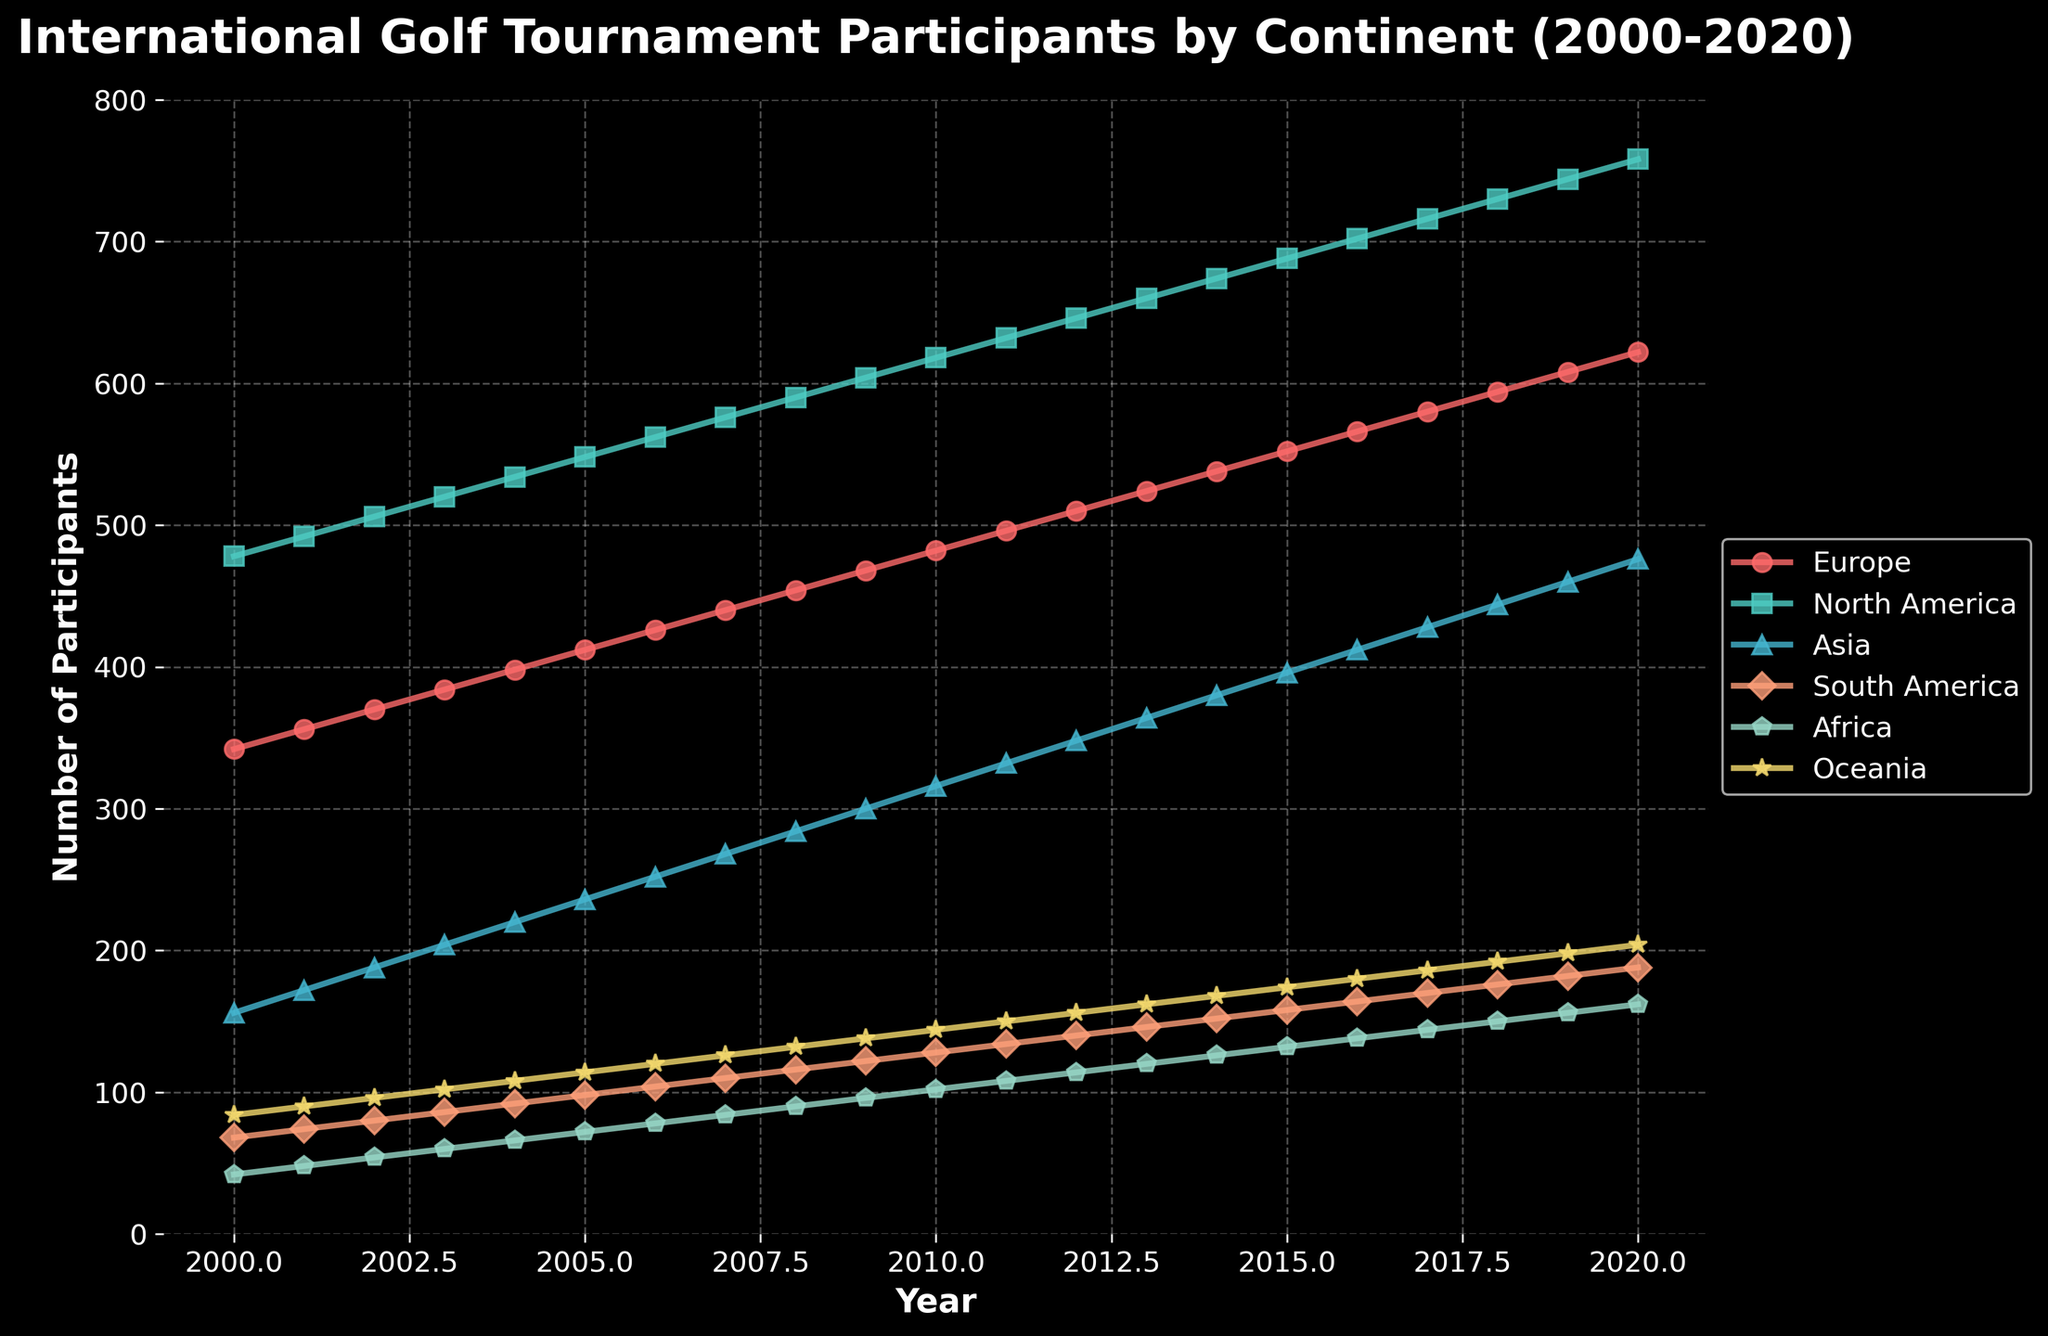Which continent had the most participants every year from 2000 to 2020? The highest line in the graph consistently represents North America, indicating that it had the most participants each year.
Answer: North America What is the average number of participants in Oceania from 2000 to 2020? The sum of participants in Oceania each year from 2000 to 2020 is 84+90+96+102+108+114+120+126+132+138+144+150+156+162+168+174+180+186+192+198+204 = 2776. There are 21 years, so the average is 2776 / 21 ≈ 132.2
Answer: 132.2 By how much did the number of participants from Asia increase from 2000 to 2020? In 2000, Asia had 156 participants, and by 2020, it had 476 participants. The increase is 476 - 156 = 320.
Answer: 320 Which continent had the closest number of participants to Europe in 2010? In 2010, Europe had 482 participants. North America had the closest with 618 participants. The difference is 618 - 482 = 136, while other continents had larger differences.
Answer: North America Overall, did any continent experience a decrease in the number of participants from 2000 to 2020? By observing the trend of each line, all lines show an increasing trend from 2000 to 2020, indicating no continent experienced a decrease.
Answer: No Which continent showed the most significant growth in participants between 2003 and 2013? Between 2003 and 2013, Asia grew from 204 participants to 364 participants. The growth is 364 - 204 = 160. Comparing with other continents, Asia had the most significant growth.
Answer: Asia What is the difference in participants between Africa and South America in 2020? In 2020, Africa had 162 participants and South America had 188. The difference is 188 - 162 = 26.
Answer: 26 Which two continents have the most similar number of participants in 2015? In 2015, South America had 158 participants and Africa had 132, making the difference 26. No other pair is closer in value.
Answer: South America and Africa Considering the trend, predict the number of participants in North America in 2025 if the trend continues. The growth rate in North America from 2000 (478) to 2020 (758) is (758 - 478) / 20 = 14 participants per year. Predicting for 2025, 758 + 5*14 = 828.
Answer: 828 Which year did Europe first surpass 500 participants? Europe first surpassed 500 participants in 2012, as 496 in 2011 and 510 in 2012.
Answer: 2012 